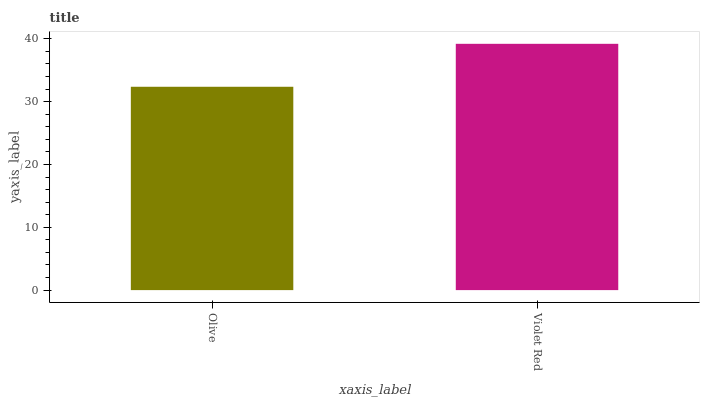Is Olive the minimum?
Answer yes or no. Yes. Is Violet Red the maximum?
Answer yes or no. Yes. Is Violet Red the minimum?
Answer yes or no. No. Is Violet Red greater than Olive?
Answer yes or no. Yes. Is Olive less than Violet Red?
Answer yes or no. Yes. Is Olive greater than Violet Red?
Answer yes or no. No. Is Violet Red less than Olive?
Answer yes or no. No. Is Violet Red the high median?
Answer yes or no. Yes. Is Olive the low median?
Answer yes or no. Yes. Is Olive the high median?
Answer yes or no. No. Is Violet Red the low median?
Answer yes or no. No. 